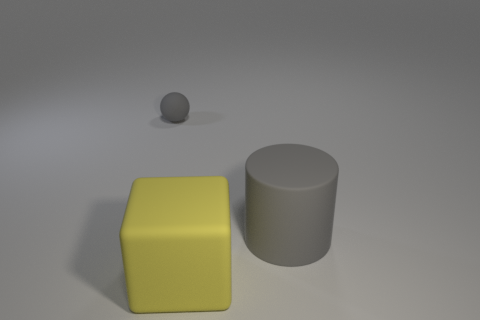Does this image remind you of any particular style or era? The image has a minimalistic quality with geometric shapes that might suggest modernism or a focus on fundamental form and color reminiscent of the Bauhaus movement. 